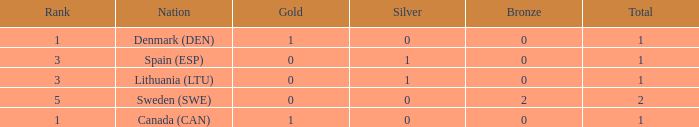What is the total when there were less than 0 bronze? 0.0. Could you parse the entire table? {'header': ['Rank', 'Nation', 'Gold', 'Silver', 'Bronze', 'Total'], 'rows': [['1', 'Denmark (DEN)', '1', '0', '0', '1'], ['3', 'Spain (ESP)', '0', '1', '0', '1'], ['3', 'Lithuania (LTU)', '0', '1', '0', '1'], ['5', 'Sweden (SWE)', '0', '0', '2', '2'], ['1', 'Canada (CAN)', '1', '0', '0', '1']]} 